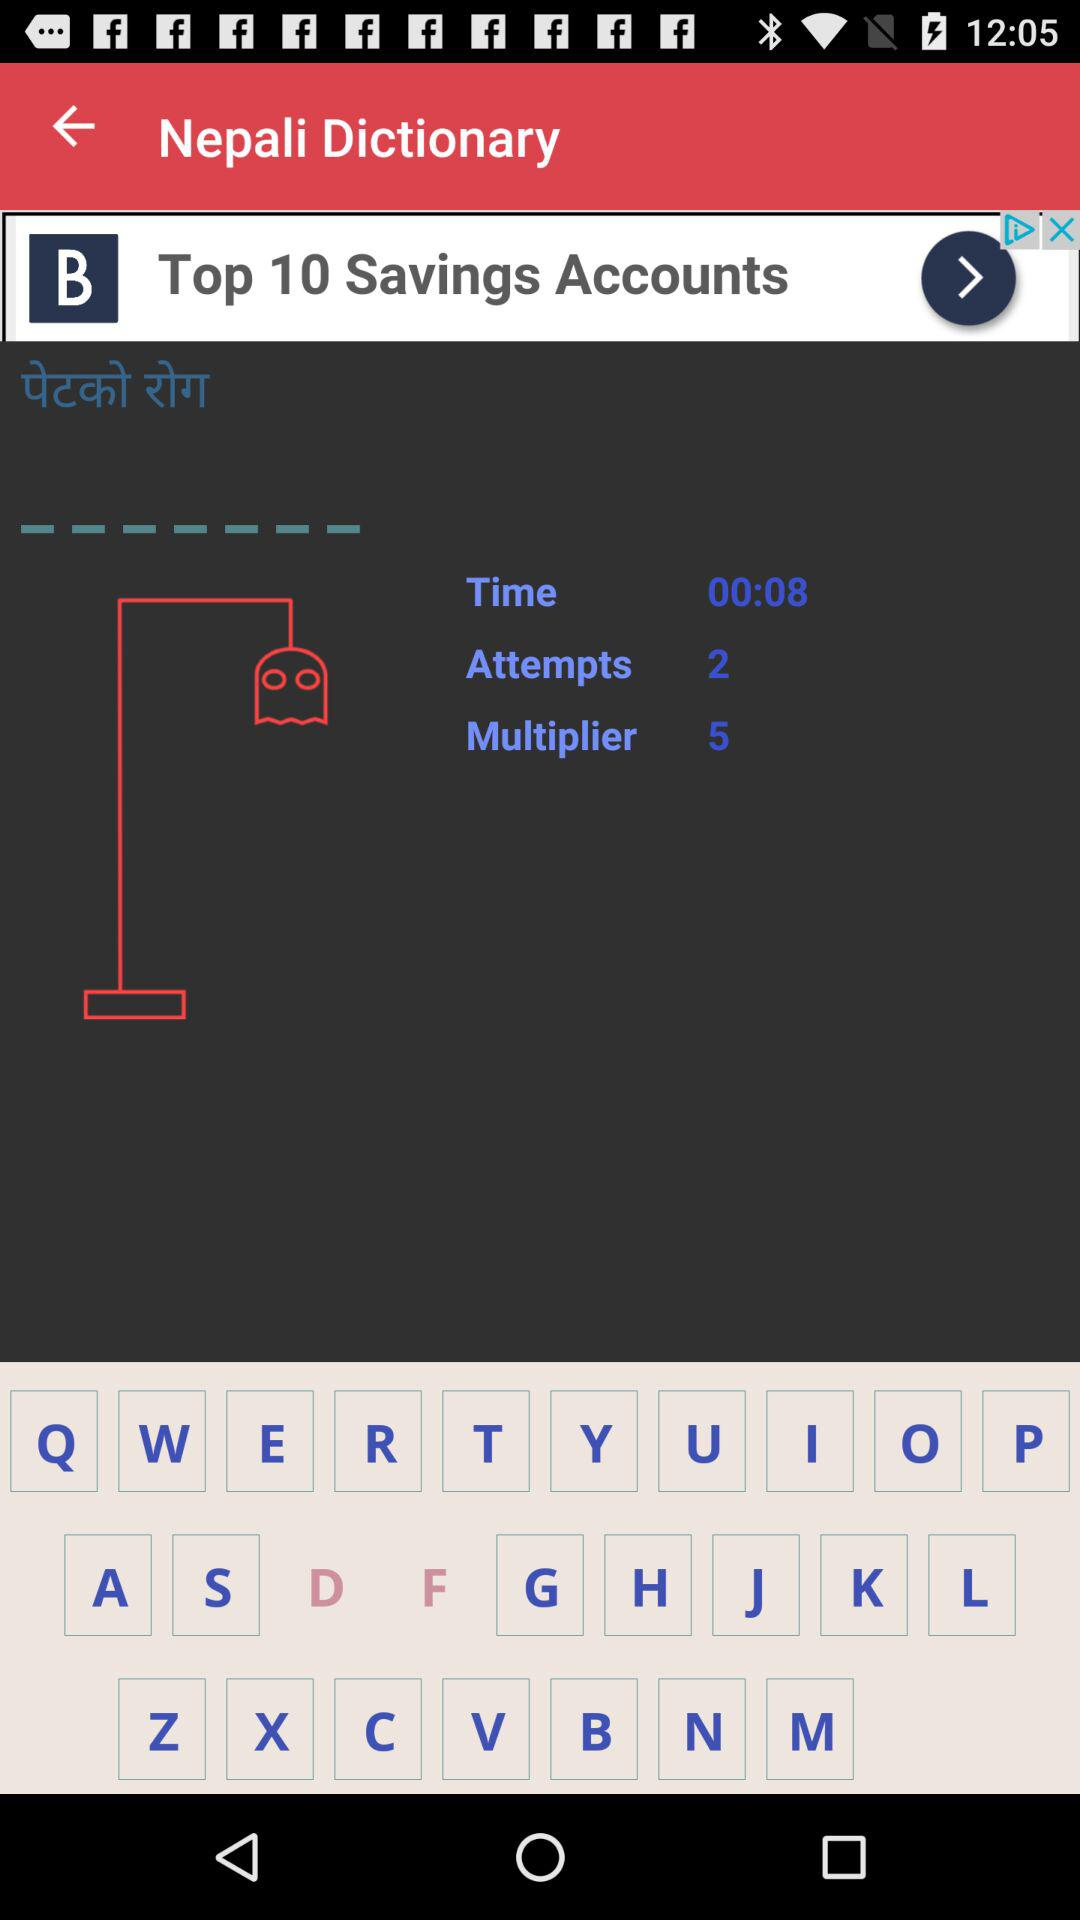What is the time given in the timer? The time given in the timer is 00:08. 